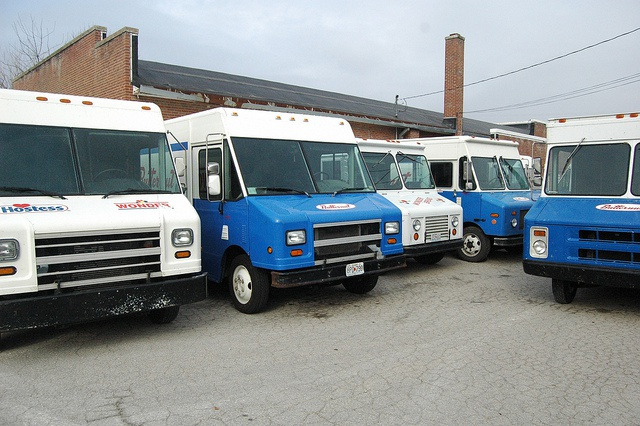Describe the objects in this image and their specific colors. I can see truck in lightblue, white, black, purple, and darkgray tones, truck in lightblue, black, white, and blue tones, truck in lightblue, black, blue, lightgray, and gray tones, truck in lightblue, lightgray, black, blue, and gray tones, and truck in lightblue, lightgray, black, gray, and darkgray tones in this image. 